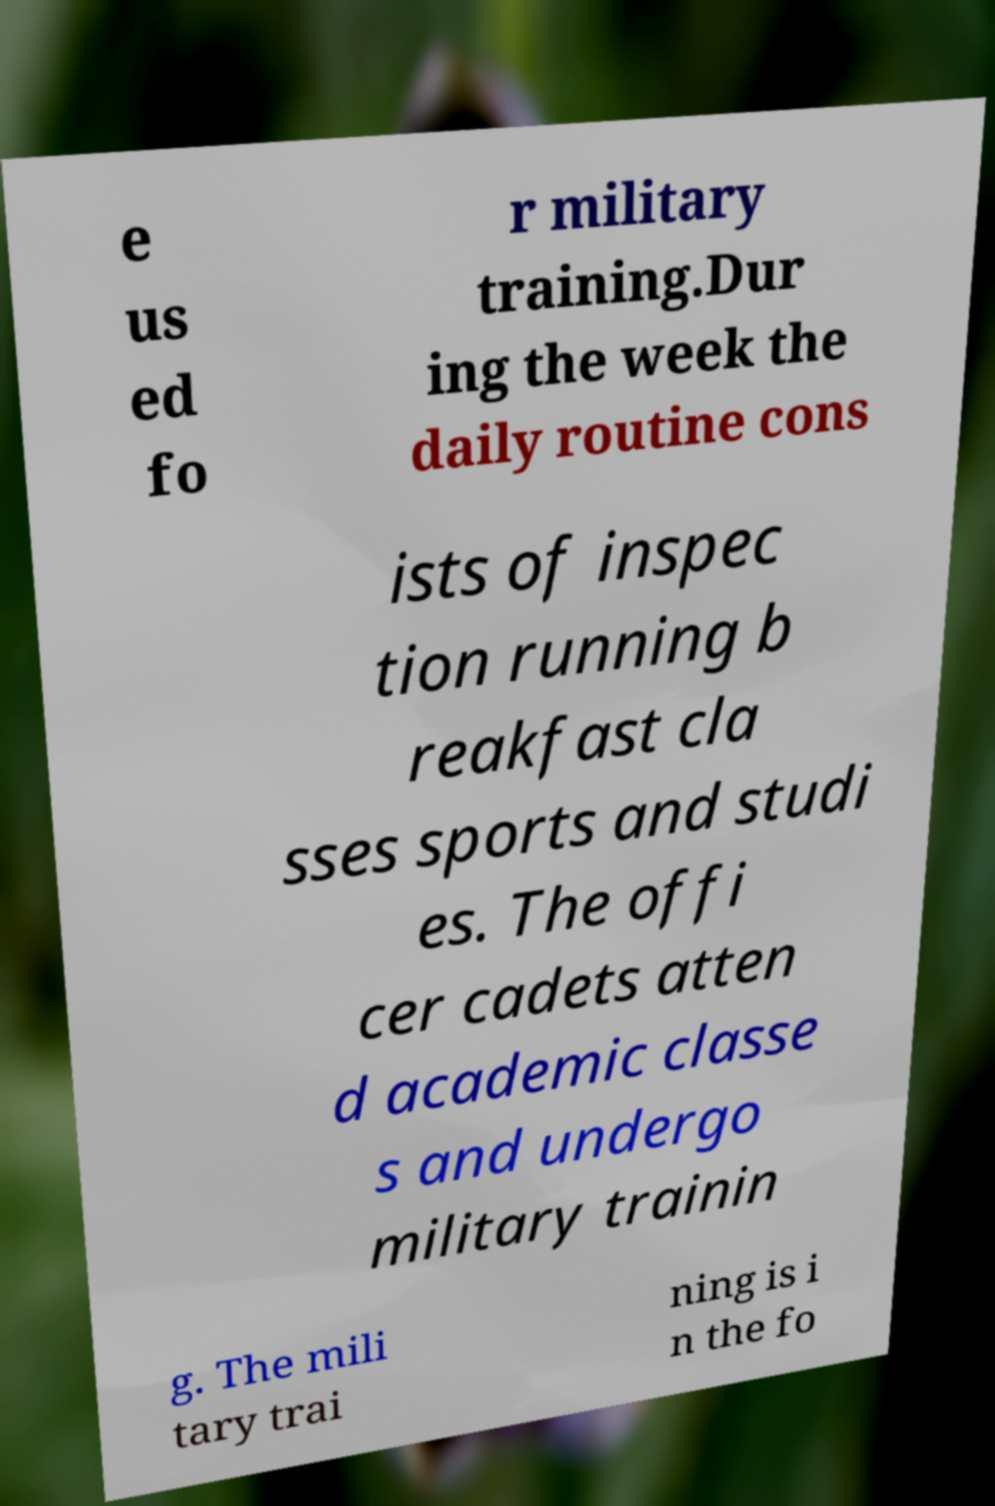Can you accurately transcribe the text from the provided image for me? e us ed fo r military training.Dur ing the week the daily routine cons ists of inspec tion running b reakfast cla sses sports and studi es. The offi cer cadets atten d academic classe s and undergo military trainin g. The mili tary trai ning is i n the fo 